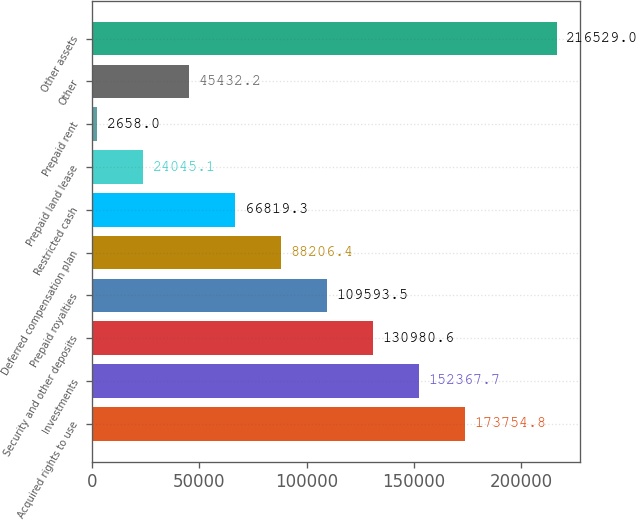<chart> <loc_0><loc_0><loc_500><loc_500><bar_chart><fcel>Acquired rights to use<fcel>Investments<fcel>Security and other deposits<fcel>Prepaid royalties<fcel>Deferred compensation plan<fcel>Restricted cash<fcel>Prepaid land lease<fcel>Prepaid rent<fcel>Other<fcel>Other assets<nl><fcel>173755<fcel>152368<fcel>130981<fcel>109594<fcel>88206.4<fcel>66819.3<fcel>24045.1<fcel>2658<fcel>45432.2<fcel>216529<nl></chart> 